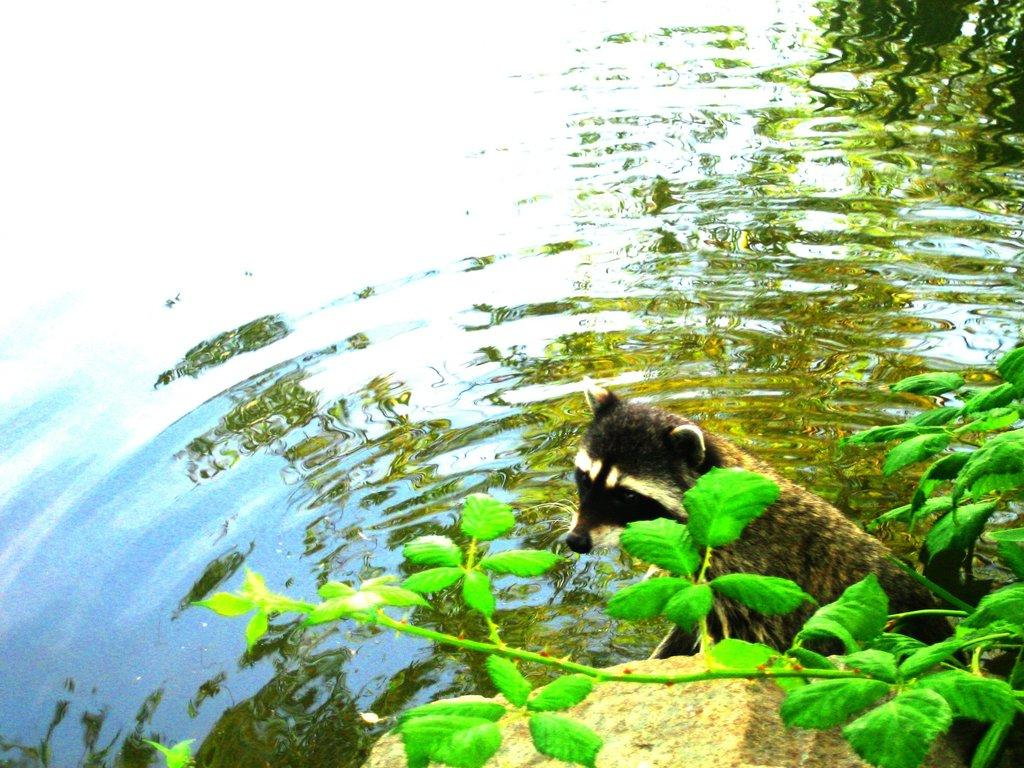What is the primary element present in the image? There is water in the image. What type of living creature can be seen in the image? There is an animal in the image. What celestial bodies are visible in the image? There are planets visible in the image. What type of inanimate object is present in the image? There is a stone in the image. Where is the alley located in the image? There is no alley present in the image. What type of pig can be seen in the image? There is no pig present in the image. 